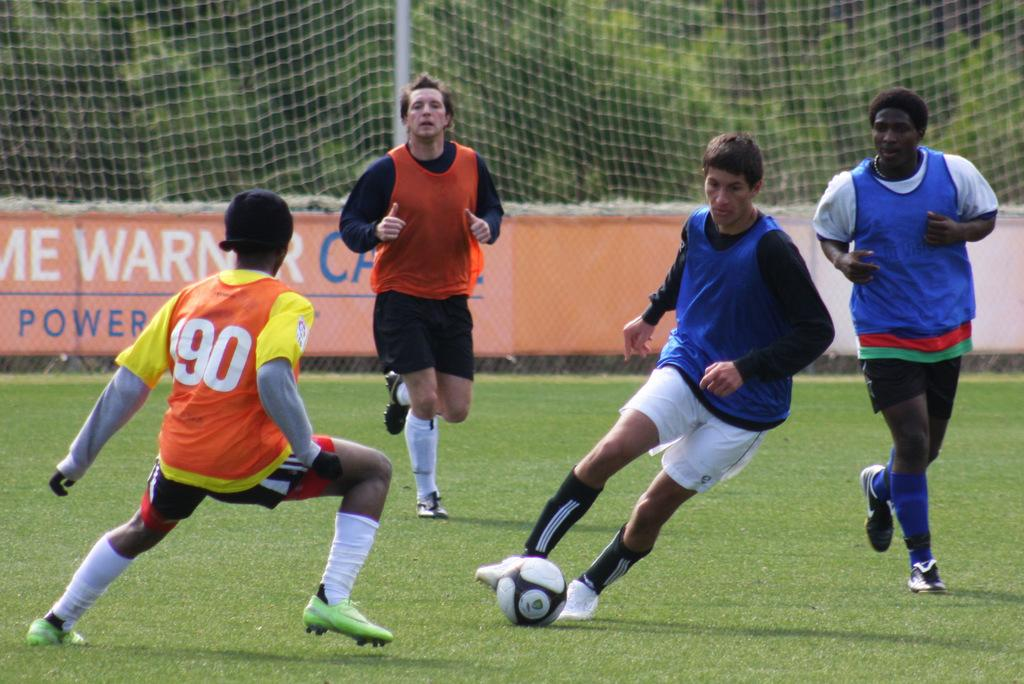<image>
Relay a brief, clear account of the picture shown. A boy wearing soccer jersey number 90 is playing defense. 